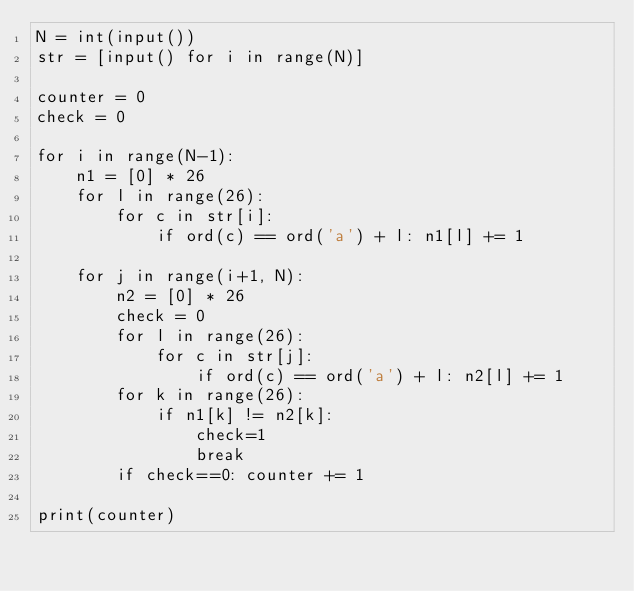Convert code to text. <code><loc_0><loc_0><loc_500><loc_500><_Python_>N = int(input())
str = [input() for i in range(N)]

counter = 0
check = 0

for i in range(N-1):
    n1 = [0] * 26
    for l in range(26):
        for c in str[i]:
            if ord(c) == ord('a') + l: n1[l] += 1

    for j in range(i+1, N):
        n2 = [0] * 26
        check = 0
        for l in range(26):
            for c in str[j]:
                if ord(c) == ord('a') + l: n2[l] += 1
        for k in range(26):
            if n1[k] != n2[k]:
                check=1
                break
        if check==0: counter += 1

print(counter)
</code> 